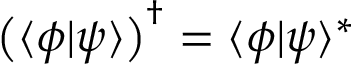<formula> <loc_0><loc_0><loc_500><loc_500>{ \left ( } \langle \phi | \psi \rangle { \right ) } ^ { \dagger } = \langle \phi | \psi \rangle ^ { * }</formula> 